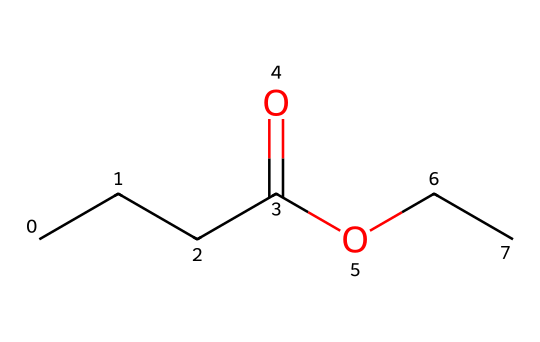What is the name of this ester? The given SMILES representation indicates the chemical structure corresponds to ethyl butyrate, as it contains the ethyl group (OCC) and butyric acid (CCCC(=O)).
Answer: ethyl butyrate How many carbon atoms are in ethyl butyrate? By analyzing the SMILES, there are a total of five carbon atoms: four from the butyrate part (CCCC) and one from the ethyl part (C in OCC).
Answer: five What type of functional group is present in this chemical? The SMILES representation indicates the presence of a carboxylate linkage (C(=O)O), characteristic of esters.
Answer: ester How many oxygen atoms are in this molecule? In the SMILES, there are two oxygen atoms: one in the carboxylate (C(=O)O) and one in the ethyl group (OCC).
Answer: two What type of odor is typically associated with ethyl butyrate? Ethyl butyrate is known for its fruity smell, reminiscent of tropical fruits like pineapples and mangoes, due to its structure and volatility.
Answer: fruity What would be the effect of increased branching in the carbon chain on the properties of this ester? Increasing branching generally lowers the volatility and can lead to a more complex scent; it may also affect the molecular interactions and solubility. Thus, the fruity character might vary.
Answer: varied 